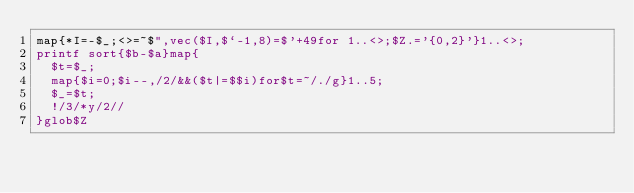Convert code to text. <code><loc_0><loc_0><loc_500><loc_500><_Perl_>map{*I=-$_;<>=~$",vec($I,$`-1,8)=$'+49for 1..<>;$Z.='{0,2}'}1..<>;
printf sort{$b-$a}map{
	$t=$_;
	map{$i=0;$i--,/2/&&($t|=$$i)for$t=~/./g}1..5;
	$_=$t;
	!/3/*y/2//
}glob$Z</code> 